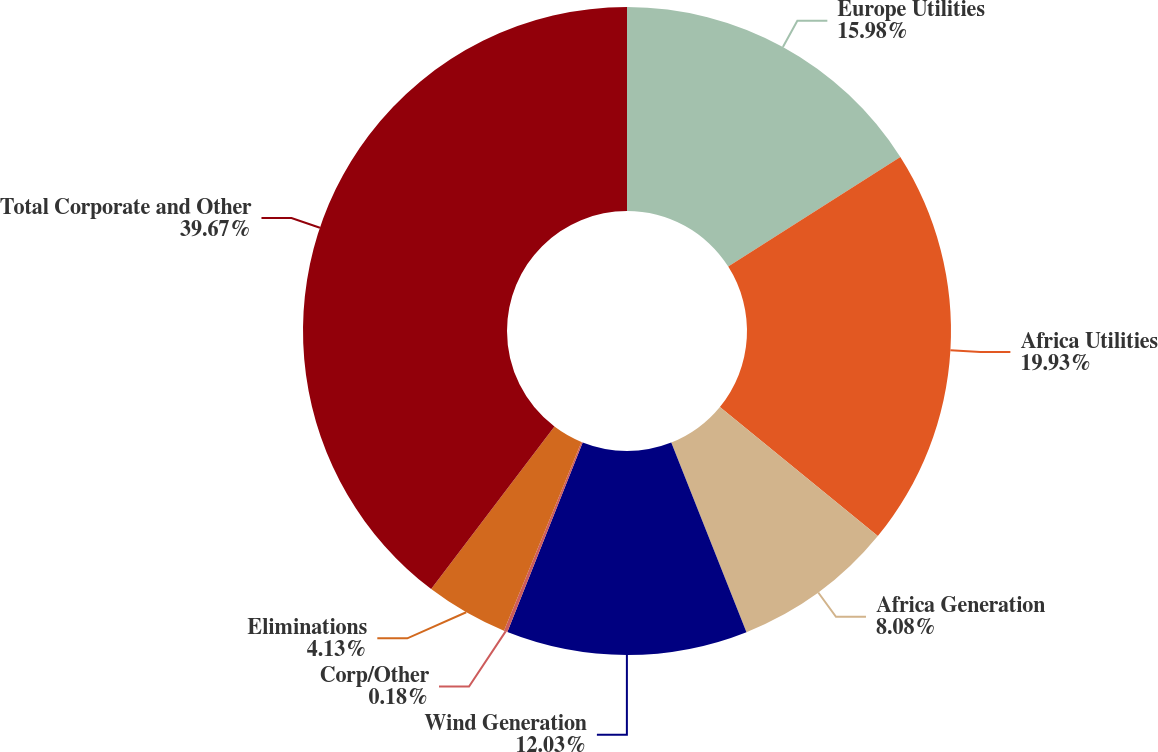<chart> <loc_0><loc_0><loc_500><loc_500><pie_chart><fcel>Europe Utilities<fcel>Africa Utilities<fcel>Africa Generation<fcel>Wind Generation<fcel>Corp/Other<fcel>Eliminations<fcel>Total Corporate and Other<nl><fcel>15.98%<fcel>19.93%<fcel>8.08%<fcel>12.03%<fcel>0.18%<fcel>4.13%<fcel>39.67%<nl></chart> 